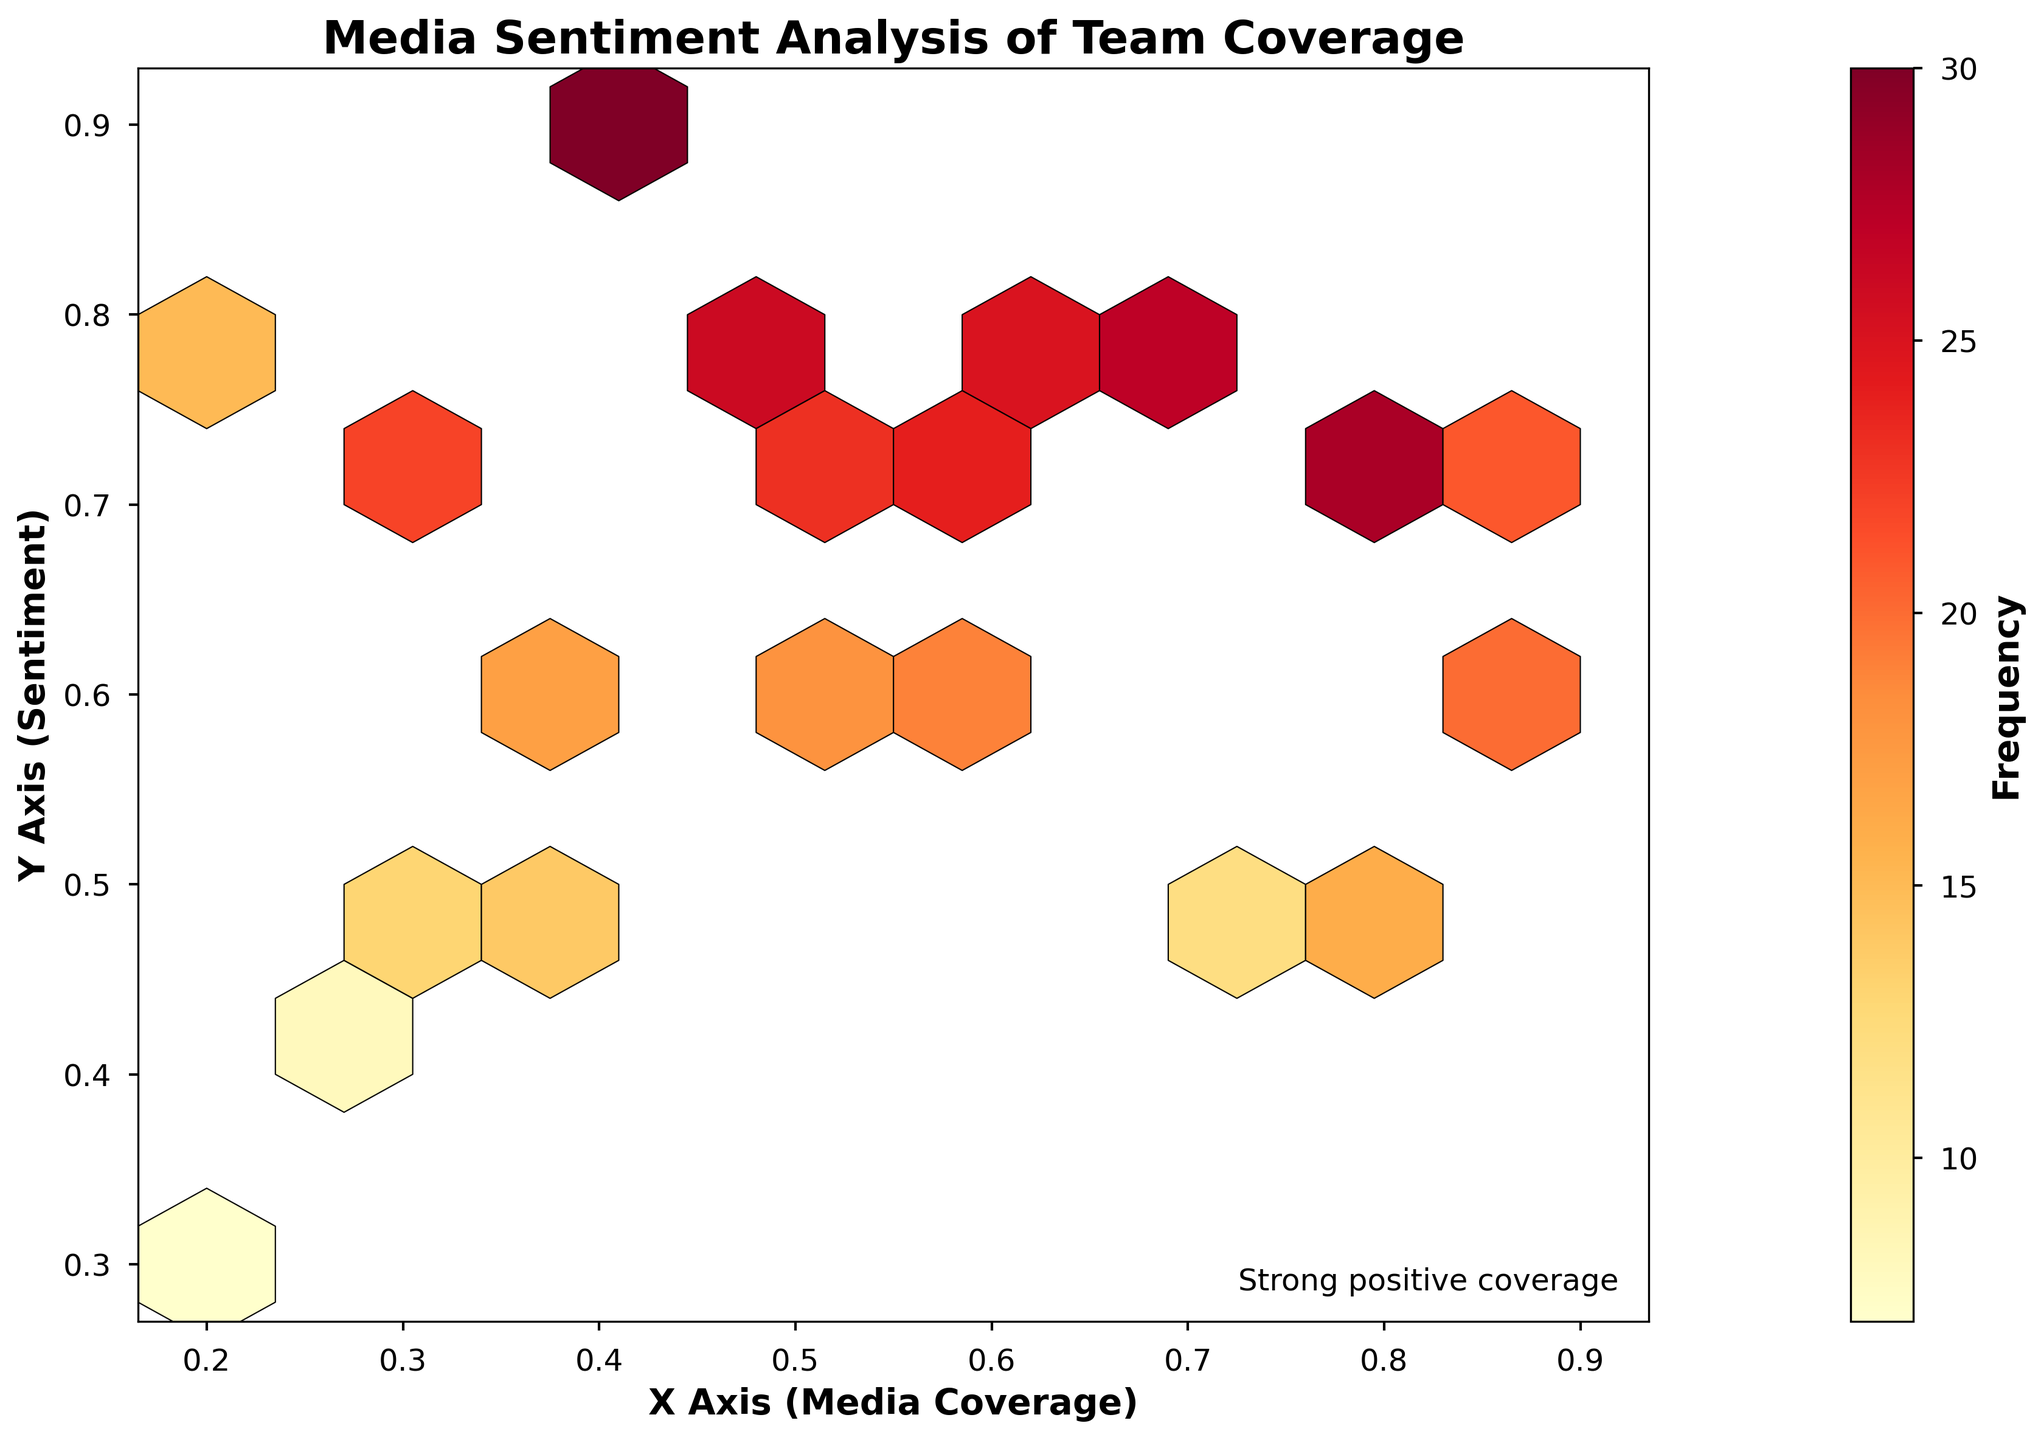What is the title of the hexbin plot? The title is usually placed at the top center of the plot and clearly indicates what the plot is about. In this case, the title "Media Sentiment Analysis of Team Coverage" is present to describe the plot.
Answer: Media Sentiment Analysis of Team Coverage What do the x and y axes represent in the plot? The labels for the axes are included in the plot to describe what each axis represents. The x-axis label is "X Axis (Media Coverage)" and the y-axis label is "Y Axis (Sentiment)".
Answer: Media Coverage (x-axis) and Sentiment (y-axis) What is the color scale used in the plot? The color scale is shown through the color bar, usually on the right side of the plot. In this figure, the color scale ranges from yellow to red, representing frequency distribution.
Answer: Yellow to Red How many hexagons exhibit a yellowish color? By examining the figure, hexagons with a yellowish color are located in areas of lower frequency. You can count them by identifying areas with light yellow shades.
Answer: Two Which hexagon has the highest frequency and what is its location? The hexagon with the darkest color (deep red) represents the highest frequency. By observing the color bar, the hexagon at the coordinates (0.4, 0.9) has the highest frequency.
Answer: (0.4, 0.9) What text is placed at the corner of the plot and what does it indicate? The text "Strong positive coverage" is placed at the bottom-right corner of the plot. This text signifies that areas in the plot close to this corner represent strong positive media coverage.
Answer: Strong positive coverage How does the frequency change as you move from the bottom-left to the top-right of the plot? By observing the color gradient, starting from lighter to darker colors, the frequency increases as you move from the bottom-left to the top-right. This indicates higher concentration of data points in this trajectory.
Answer: Increases Is there a higher concentration of data points in areas of higher media coverage or lower media coverage? By examining the density of hexagons, the visualization indicates that there are more concentrated data points in the higher media coverage areas, especially around the upper-right section.
Answer: Higher media coverage areas Describe the sentiment spread across media coverage. To answer this, observe the y-axis distribution at different x-axis values. The sentiment ranges from lower values (around 0.3) to higher values (around 0.9), with a general trend towards higher sentiments with increased media coverage.
Answer: Higher sentiments with increased media coverage What is the predominant color in the plot and what does it signify about the distribution of frequencies? The predominant color is orange and light red, which indicates moderately high frequencies. This suggests that most hexagons have a balanced distribution across different levels of frequency.
Answer: Orange and light red signifying moderate frequencies 